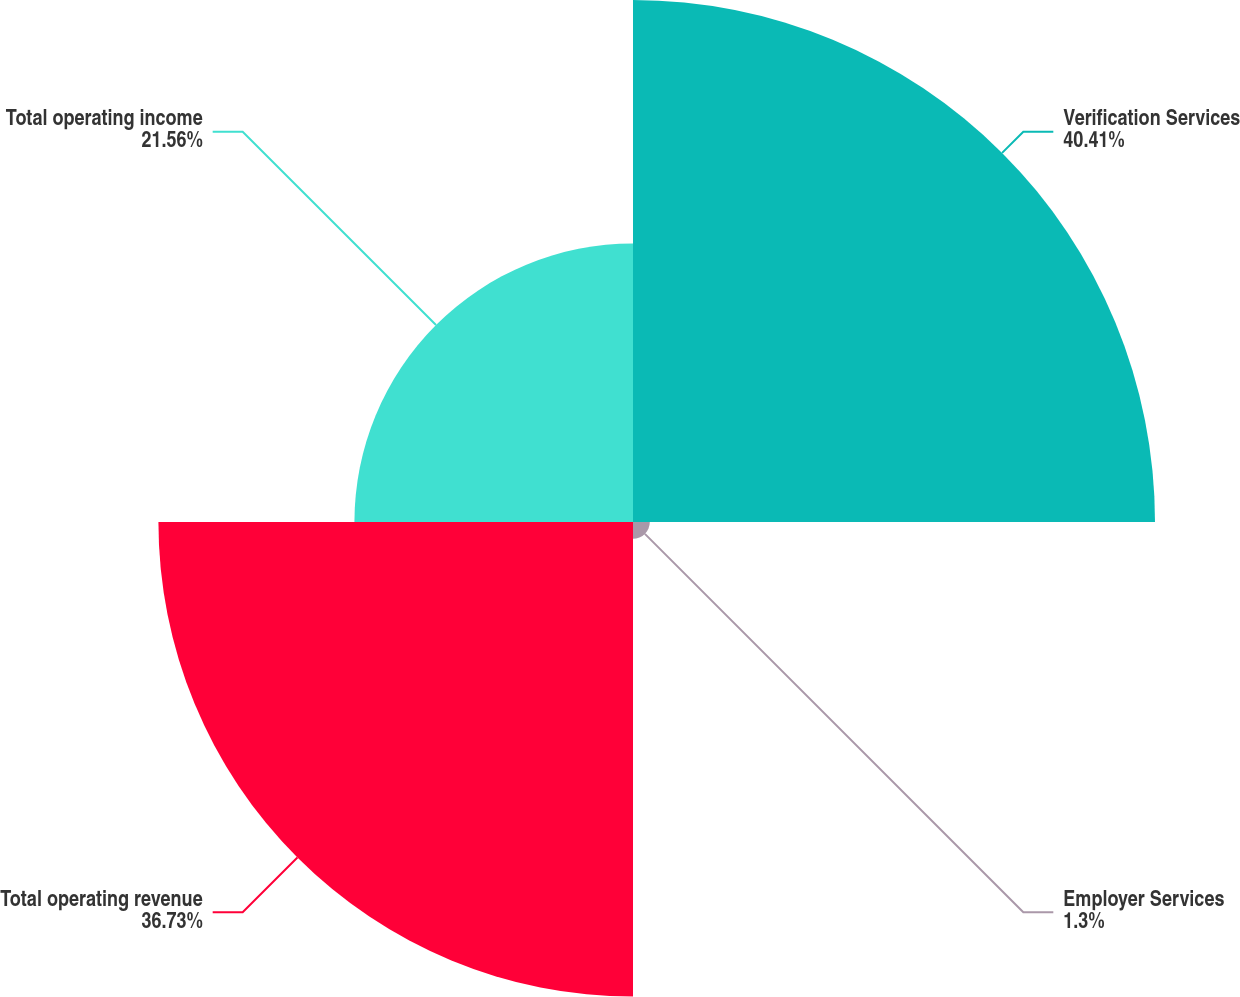Convert chart. <chart><loc_0><loc_0><loc_500><loc_500><pie_chart><fcel>Verification Services<fcel>Employer Services<fcel>Total operating revenue<fcel>Total operating income<nl><fcel>40.4%<fcel>1.3%<fcel>36.73%<fcel>21.56%<nl></chart> 